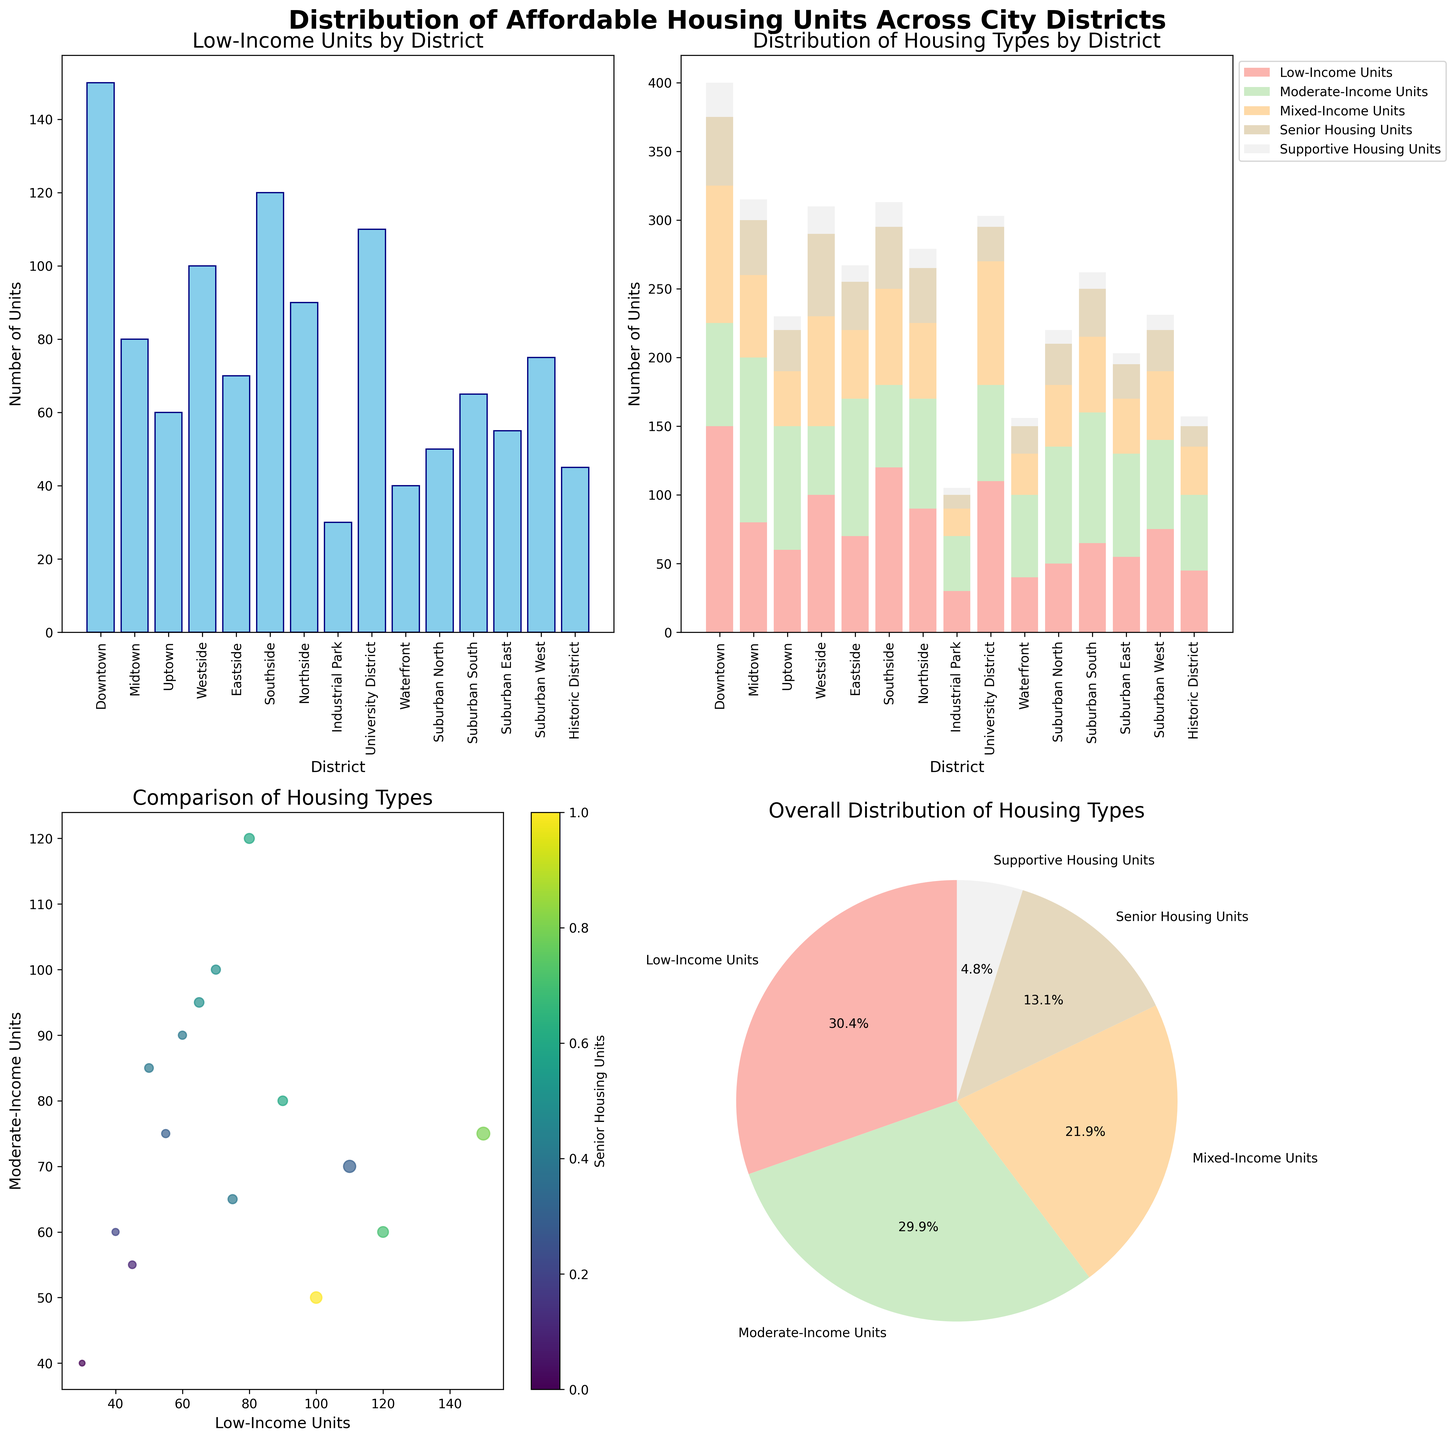Which district has the highest number of low-income units? Look at the bar plot titled "Low-Income Units by District." Find the bar that is the tallest.
Answer: Downtown Which housing type has the smallest overall distribution in the pie chart? Refer to the pie chart "Overall Distribution of Housing Types" and identify the wedge with the smallest segment.
Answer: Supportive Housing Units Compare the number of low-income units in Downtown and Midtown districts. Which has more units? In the bar plot "Low-Income Units by District," compare the height of the bars for Downtown and Midtown.
Answer: Downtown How many more mixed-income units are there in the University District compared to the Industrial Park? Find the mixed-income units for both districts in the stacked bar plot. Calculate the difference (90 units - 20 units).
Answer: 70 units Which district has the highest proportion of moderate-income units among all the districts? In the stacked bar plot, the taller bar segment for moderate-income units can be compared across districts.
Answer: Midtown What is the range of senior housing units across all districts? Look at the scatter plot and observe the color-coded range for "Senior Housing Units." Identify the maximum and minimum values (max = 60, min = 5). Subtract the minimum from the maximum.
Answer: 55 units Rank the districts from highest to lowest in terms of supportive housing units. Refer to the supportive housing units in the stacked bar plot and list them in descending order.
Answer: Downtown, Southside, Westside, Northside, Midtown, Eastside, Eastside, Suburban South, Suburban North, Waterfront, Suburban West, Suburban East, University District, Historic District, Industrial Park Which scatter plot point represents a district with the highest number of mixed-income units? Identify the largest scatter point size since larger sizes denote higher mixed-income units.
Answer: University District What is the sum of low-income and moderate-income units in Suburban South? Find the values for Suburban South in the stacked bar plot and sum these two quantities (65 + 95).
Answer: 160 units Which district has the most senior housing units according to the scatter plot? Look for the scatter plot point with the darkest color representing the highest "Senior Housing Units."
Answer: Westside 